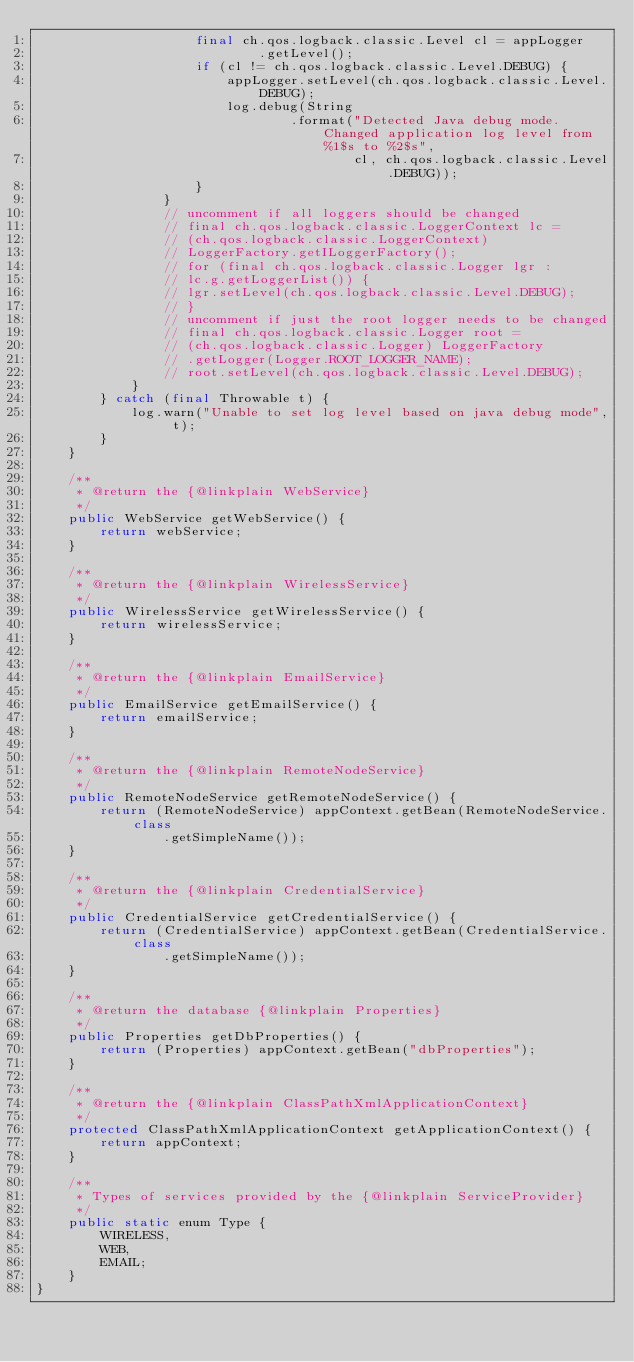Convert code to text. <code><loc_0><loc_0><loc_500><loc_500><_Java_>					final ch.qos.logback.classic.Level cl = appLogger
							.getLevel();
					if (cl != ch.qos.logback.classic.Level.DEBUG) {
						appLogger.setLevel(ch.qos.logback.classic.Level.DEBUG);
						log.debug(String
								.format("Detected Java debug mode. Changed application log level from %1$s to %2$s",
										cl, ch.qos.logback.classic.Level.DEBUG));
					}
				}
				// uncomment if all loggers should be changed
				// final ch.qos.logback.classic.LoggerContext lc =
				// (ch.qos.logback.classic.LoggerContext)
				// LoggerFactory.getILoggerFactory();
				// for (final ch.qos.logback.classic.Logger lgr :
				// lc.g.getLoggerList()) {
				// lgr.setLevel(ch.qos.logback.classic.Level.DEBUG);
				// }
				// uncomment if just the root logger needs to be changed
				// final ch.qos.logback.classic.Logger root =
				// (ch.qos.logback.classic.Logger) LoggerFactory
				// .getLogger(Logger.ROOT_LOGGER_NAME);
				// root.setLevel(ch.qos.logback.classic.Level.DEBUG);
			}
		} catch (final Throwable t) {
			log.warn("Unable to set log level based on java debug mode", t);
		}
	}

	/**
	 * @return the {@linkplain WebService}
	 */
	public WebService getWebService() {
		return webService;
	}

	/**
	 * @return the {@linkplain WirelessService}
	 */
	public WirelessService getWirelessService() {
		return wirelessService;
	}

	/**
	 * @return the {@linkplain EmailService}
	 */
	public EmailService getEmailService() {
		return emailService;
	}

	/**
	 * @return the {@linkplain RemoteNodeService}
	 */
	public RemoteNodeService getRemoteNodeService() {
		return (RemoteNodeService) appContext.getBean(RemoteNodeService.class
				.getSimpleName());
	}

	/**
	 * @return the {@linkplain CredentialService}
	 */
	public CredentialService getCredentialService() {
		return (CredentialService) appContext.getBean(CredentialService.class
				.getSimpleName());
	}

	/**
	 * @return the database {@linkplain Properties}
	 */
	public Properties getDbProperties() {
		return (Properties) appContext.getBean("dbProperties");
	}

	/**
	 * @return the {@linkplain ClassPathXmlApplicationContext}
	 */
	protected ClassPathXmlApplicationContext getApplicationContext() {
		return appContext;
	}

	/**
	 * Types of services provided by the {@linkplain ServiceProvider}
	 */
	public static enum Type {
		WIRELESS,
		WEB,
		EMAIL;
	}
}
</code> 